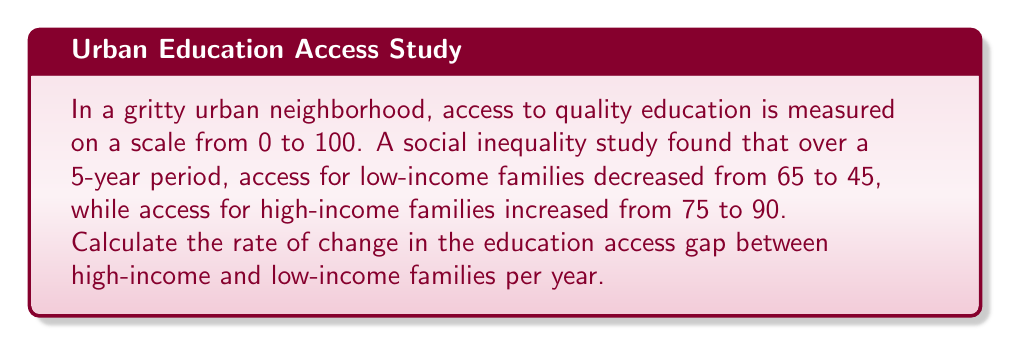Can you answer this question? Let's approach this step-by-step:

1) First, let's define our variables:
   $t$ = time in years
   $L(t)$ = access for low-income families
   $H(t)$ = access for high-income families
   $G(t)$ = gap between high-income and low-income families

2) We can express the gap as: $G(t) = H(t) - L(t)$

3) At $t=0$ (start of the period):
   $G(0) = H(0) - L(0) = 75 - 65 = 10$

4) At $t=5$ (end of the period):
   $G(5) = H(5) - L(5) = 90 - 45 = 45$

5) The change in the gap over 5 years:
   $\Delta G = G(5) - G(0) = 45 - 10 = 35$

6) To find the rate of change per year, we divide by the number of years:
   $$\text{Rate of change} = \frac{\Delta G}{\Delta t} = \frac{35}{5} = 7$$

This means the education access gap is increasing by 7 points per year.
Answer: 7 points per year 